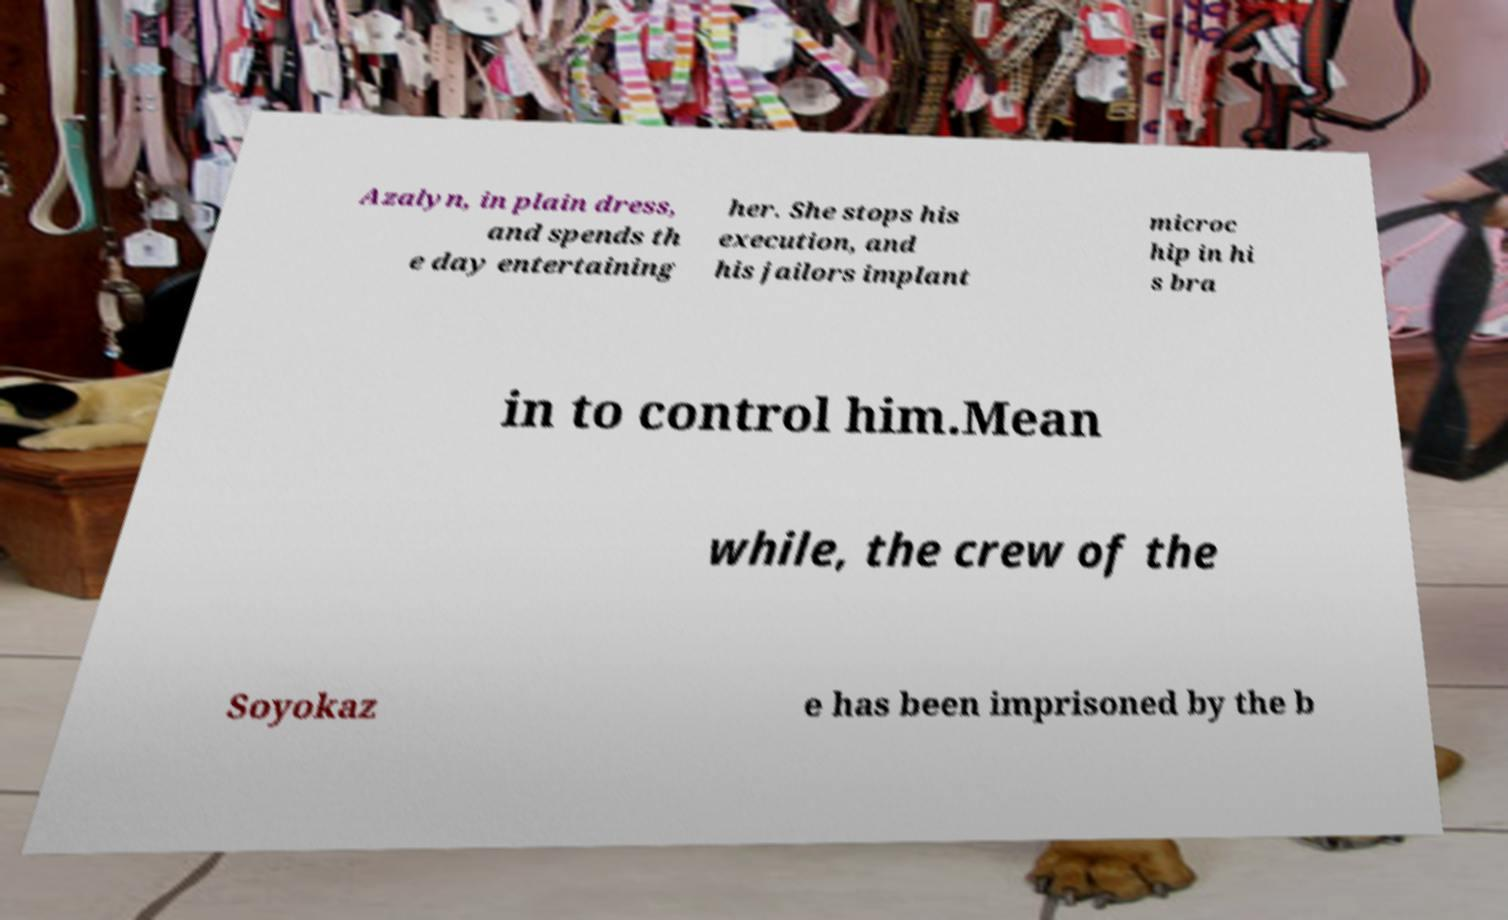Can you accurately transcribe the text from the provided image for me? Azalyn, in plain dress, and spends th e day entertaining her. She stops his execution, and his jailors implant microc hip in hi s bra in to control him.Mean while, the crew of the Soyokaz e has been imprisoned by the b 